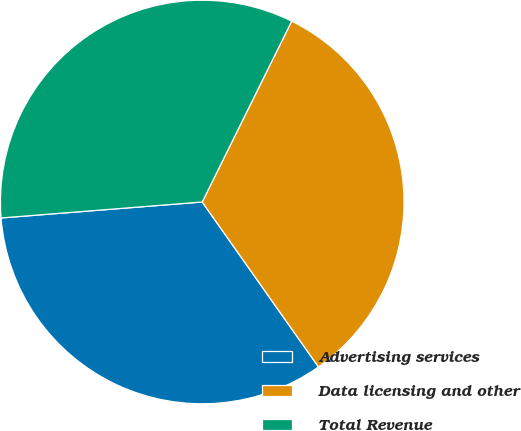<chart> <loc_0><loc_0><loc_500><loc_500><pie_chart><fcel>Advertising services<fcel>Data licensing and other<fcel>Total Revenue<nl><fcel>33.51%<fcel>32.91%<fcel>33.57%<nl></chart> 